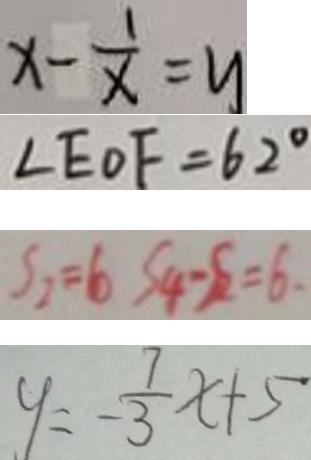Convert formula to latex. <formula><loc_0><loc_0><loc_500><loc_500>x - \frac { 1 } { x } = y 
 \angle E O F = 6 2 ^ { \circ } 
 S _ { 2 } = 6 S _ { 4 } - S _ { 2 } = 6 . 
 y = - \frac { 7 } { 3 } x + 5</formula> 